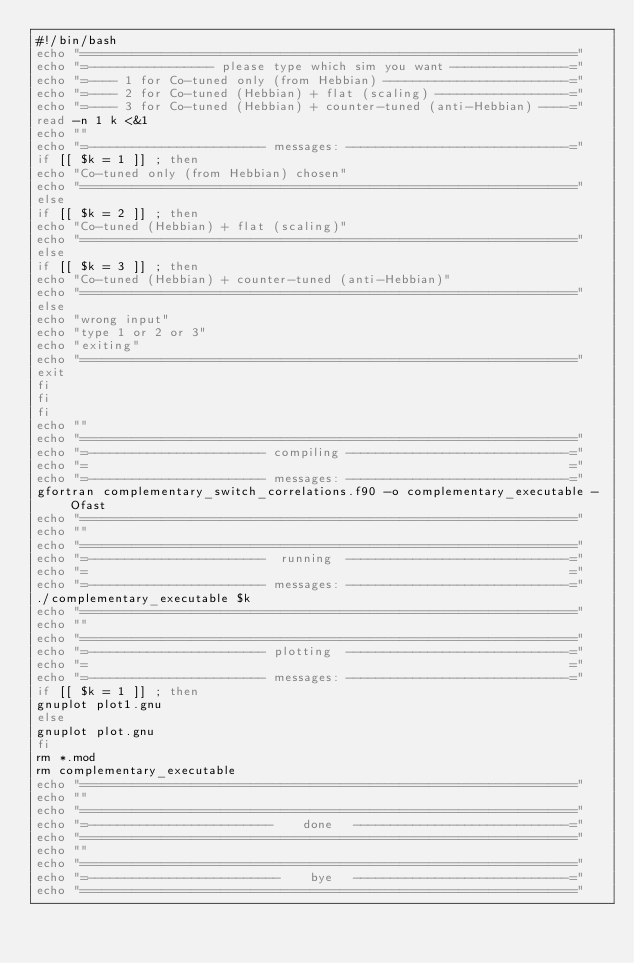<code> <loc_0><loc_0><loc_500><loc_500><_Bash_>#!/bin/bash
echo "==================================================================="
echo "=----------------- please type which sim you want ----------------="
echo "=---- 1 for Co-tuned only (from Hebbian) -------------------------="
echo "=---- 2 for Co-tuned (Hebbian) + flat (scaling) ------------------="
echo "=---- 3 for Co-tuned (Hebbian) + counter-tuned (anti-Hebbian) ----="
read -n 1 k <&1
echo ""
echo "=------------------------ messages: ------------------------------="
if [[ $k = 1 ]] ; then
echo "Co-tuned only (from Hebbian) chosen"
echo "==================================================================="
else
if [[ $k = 2 ]] ; then
echo "Co-tuned (Hebbian) + flat (scaling)"
echo "==================================================================="
else
if [[ $k = 3 ]] ; then
echo "Co-tuned (Hebbian) + counter-tuned (anti-Hebbian)"
echo "==================================================================="
else
echo "wrong input"
echo "type 1 or 2 or 3"
echo "exiting"
echo "==================================================================="
exit
fi
fi
fi
echo ""
echo "==================================================================="
echo "=------------------------ compiling ------------------------------="
echo "=                                                                 ="
echo "=------------------------ messages: ------------------------------="
gfortran complementary_switch_correlations.f90 -o complementary_executable -Ofast
echo "==================================================================="
echo ""
echo "==================================================================="
echo "=------------------------  running  ------------------------------="
echo "=                                                                 ="
echo "=------------------------ messages: ------------------------------="
./complementary_executable $k
echo "==================================================================="
echo ""
echo "==================================================================="
echo "=------------------------ plotting  ------------------------------="
echo "=                                                                 ="
echo "=------------------------ messages: ------------------------------="
if [[ $k = 1 ]] ; then
gnuplot plot1.gnu
else
gnuplot plot.gnu
fi
rm *.mod
rm complementary_executable
echo "==================================================================="
echo ""
echo "==================================================================="
echo "=-------------------------    done   -----------------------------="
echo "==================================================================="
echo ""
echo "==================================================================="
echo "=--------------------------    bye   -----------------------------="
echo "==================================================================="
</code> 